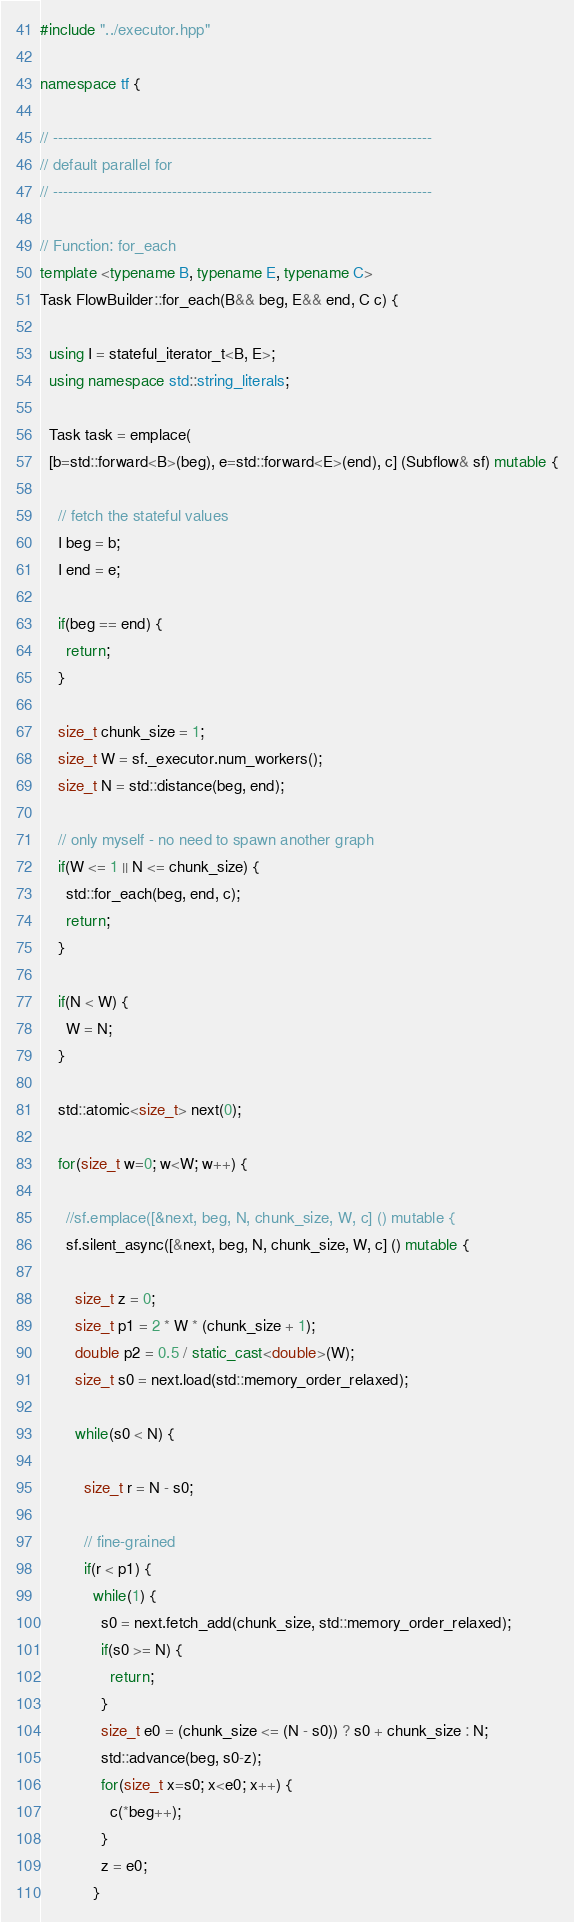<code> <loc_0><loc_0><loc_500><loc_500><_C++_>
#include "../executor.hpp"

namespace tf {

// ----------------------------------------------------------------------------
// default parallel for
// ----------------------------------------------------------------------------

// Function: for_each
template <typename B, typename E, typename C>
Task FlowBuilder::for_each(B&& beg, E&& end, C c) {
  
  using I = stateful_iterator_t<B, E>;
  using namespace std::string_literals;

  Task task = emplace(
  [b=std::forward<B>(beg), e=std::forward<E>(end), c] (Subflow& sf) mutable {
    
    // fetch the stateful values
    I beg = b;
    I end = e;

    if(beg == end) {
      return;
    }
  
    size_t chunk_size = 1;
    size_t W = sf._executor.num_workers();
    size_t N = std::distance(beg, end);
    
    // only myself - no need to spawn another graph
    if(W <= 1 || N <= chunk_size) {
      std::for_each(beg, end, c);
      return;
    }
    
    if(N < W) {
      W = N;
    }

    std::atomic<size_t> next(0);

    for(size_t w=0; w<W; w++) {

      //sf.emplace([&next, beg, N, chunk_size, W, c] () mutable {
      sf.silent_async([&next, beg, N, chunk_size, W, c] () mutable {
        
        size_t z = 0;
        size_t p1 = 2 * W * (chunk_size + 1);
        double p2 = 0.5 / static_cast<double>(W);
        size_t s0 = next.load(std::memory_order_relaxed);

        while(s0 < N) {
          
          size_t r = N - s0;
          
          // fine-grained
          if(r < p1) {
            while(1) {
              s0 = next.fetch_add(chunk_size, std::memory_order_relaxed);
              if(s0 >= N) {
                return;
              }
              size_t e0 = (chunk_size <= (N - s0)) ? s0 + chunk_size : N;
              std::advance(beg, s0-z);
              for(size_t x=s0; x<e0; x++) {
                c(*beg++);
              }
              z = e0;
            }</code> 